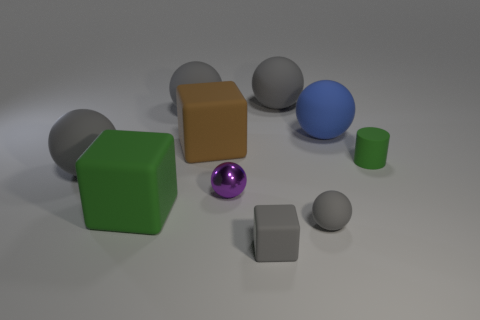How many gray spheres must be subtracted to get 2 gray spheres? 2 Subtract all brown cylinders. How many gray balls are left? 4 Subtract 3 balls. How many balls are left? 3 Subtract all purple balls. How many balls are left? 5 Subtract all tiny shiny balls. How many balls are left? 5 Subtract all brown cylinders. Subtract all blue spheres. How many cylinders are left? 1 Subtract all cylinders. How many objects are left? 9 Add 3 big blue balls. How many big blue balls exist? 4 Subtract 0 yellow cylinders. How many objects are left? 10 Subtract all large red cylinders. Subtract all large balls. How many objects are left? 6 